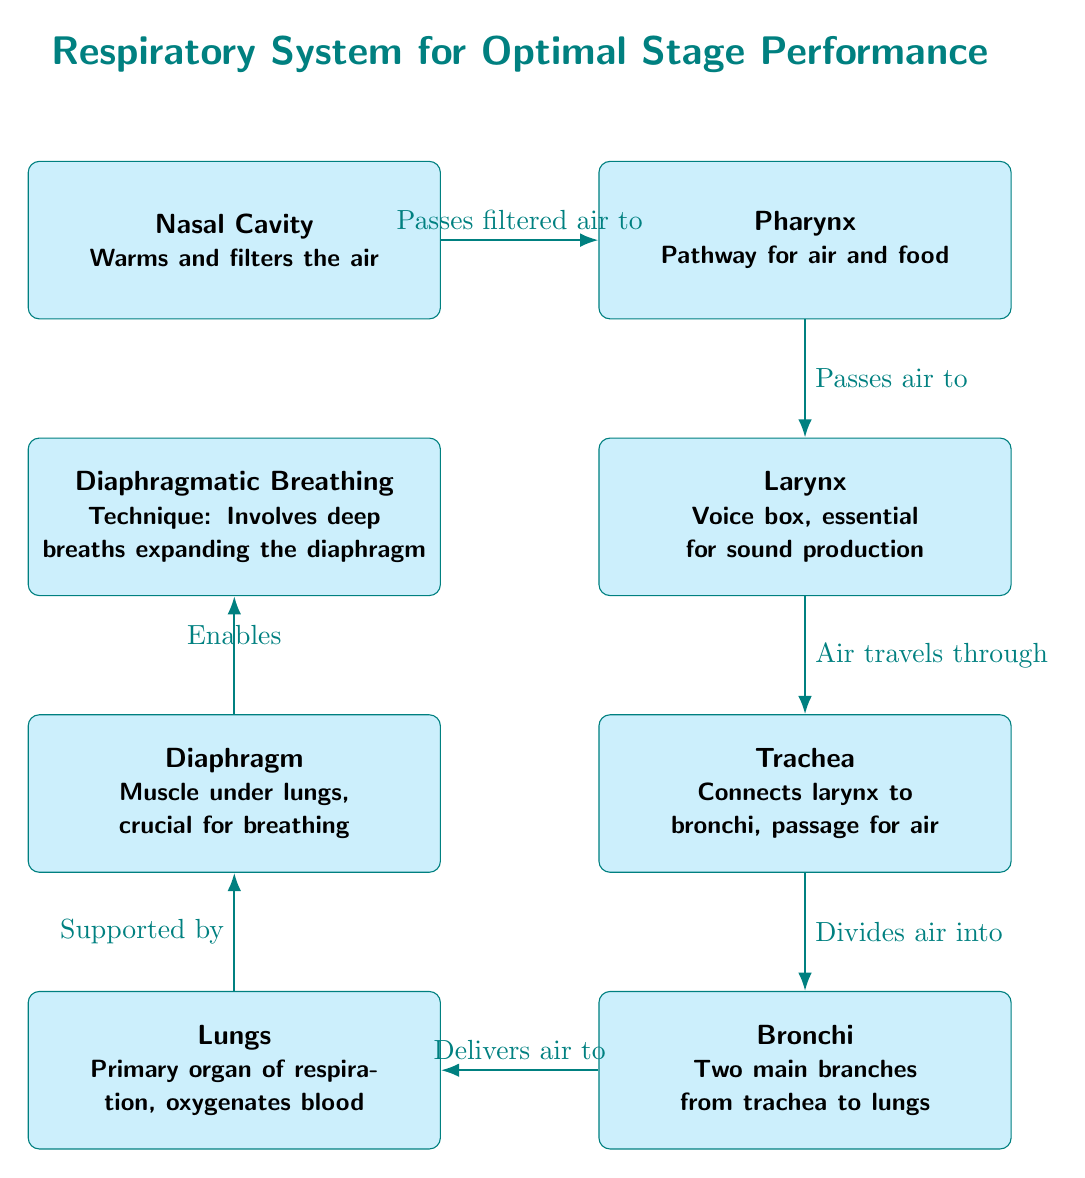What is the primary organ of respiration? The diagram identifies the Lungs as the primary organ of respiration, which is also indicated in the description provided for that node.
Answer: Lungs What does the nasal cavity do? The diagram states that the Nasal Cavity warms and filters the air, outlining its role at the beginning of the respiratory pathway.
Answer: Warms and filters the air How many main branches do the bronchi have? The diagram specifies that there are two main branches from the trachea to the lungs, as mentioned in the Bronchi node.
Answer: Two Which muscle is crucial for breathing? According to the diagram, the Diaphragm is the muscle located under the lungs and is noted as crucial for the breathing process.
Answer: Diaphragm How does air travel after passing through the larynx? The diagram shows that air travels from the Larynx through the Trachea to the Bronchi, which indicates the pathway followed after the Larynx.
Answer: Trachea What technique is mentioned in the diagram for better breath control? The diagram specifically lists Diaphragmatic Breathing as a technique that involves deep breaths, emphasizing its importance for actors.
Answer: Diaphragmatic Breathing What node connects the larynx to the bronchi? The diagram indicates the Trachea as the node connecting the Larynx to the Bronchi, serving as the passage for air.
Answer: Trachea Which element supports the lungs? The diagram clearly states that the Lungs are supported by the Diaphragm, as illustrated by the connection in the diagram.
Answer: Diaphragm What is the key benefit of diaphragmatic breathing for actors? The diagram suggests that diaphragmatic breathing enables stronger breath control and stamina by expanding the diaphragm for deeper breathing.
Answer: Enables stronger breath control What flows from the nasal cavity to the pharynx? The diagram indicates that filtered air passes from the Nasal Cavity to the Pharynx, establishing a clear pathway.
Answer: Filtered air 